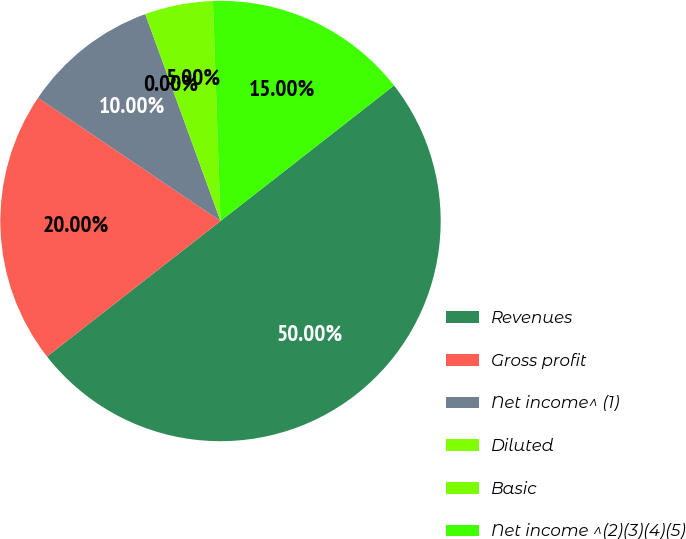Convert chart to OTSL. <chart><loc_0><loc_0><loc_500><loc_500><pie_chart><fcel>Revenues<fcel>Gross profit<fcel>Net income^ (1)<fcel>Diluted<fcel>Basic<fcel>Net income ^(2)(3)(4)(5)<nl><fcel>50.0%<fcel>20.0%<fcel>10.0%<fcel>0.0%<fcel>5.0%<fcel>15.0%<nl></chart> 